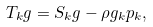Convert formula to latex. <formula><loc_0><loc_0><loc_500><loc_500>T _ { k } g = S _ { k } g - \rho g _ { k } p _ { k } ,</formula> 